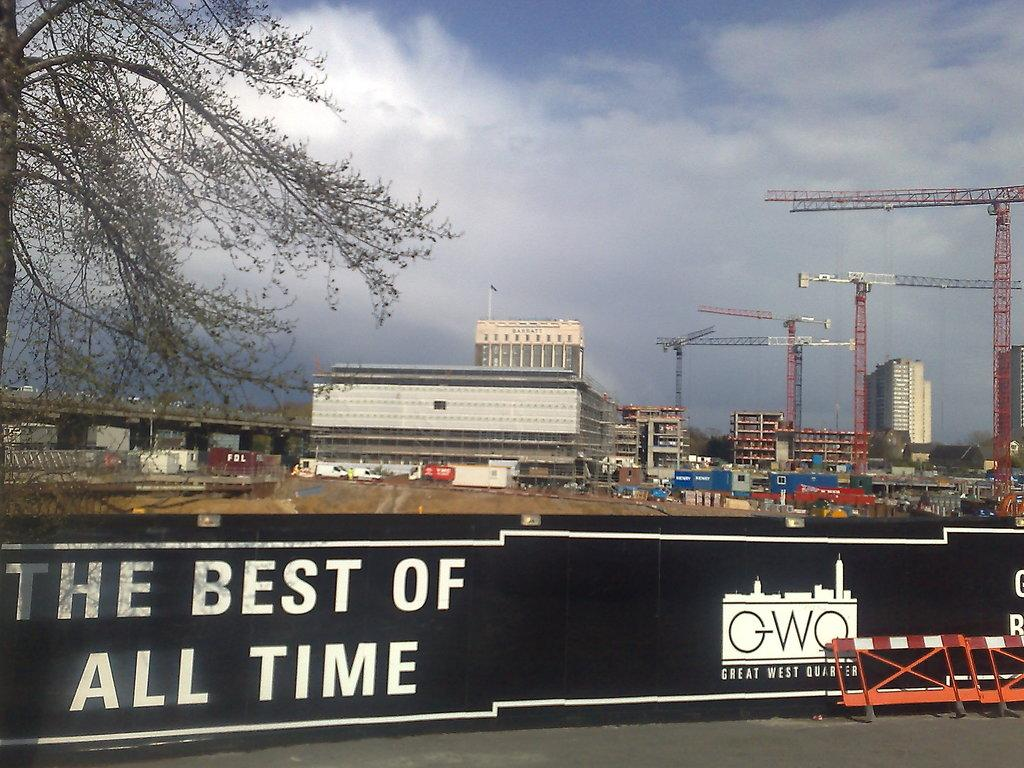<image>
Share a concise interpretation of the image provided. A banner on the side of the road says "The Best of All Time" 